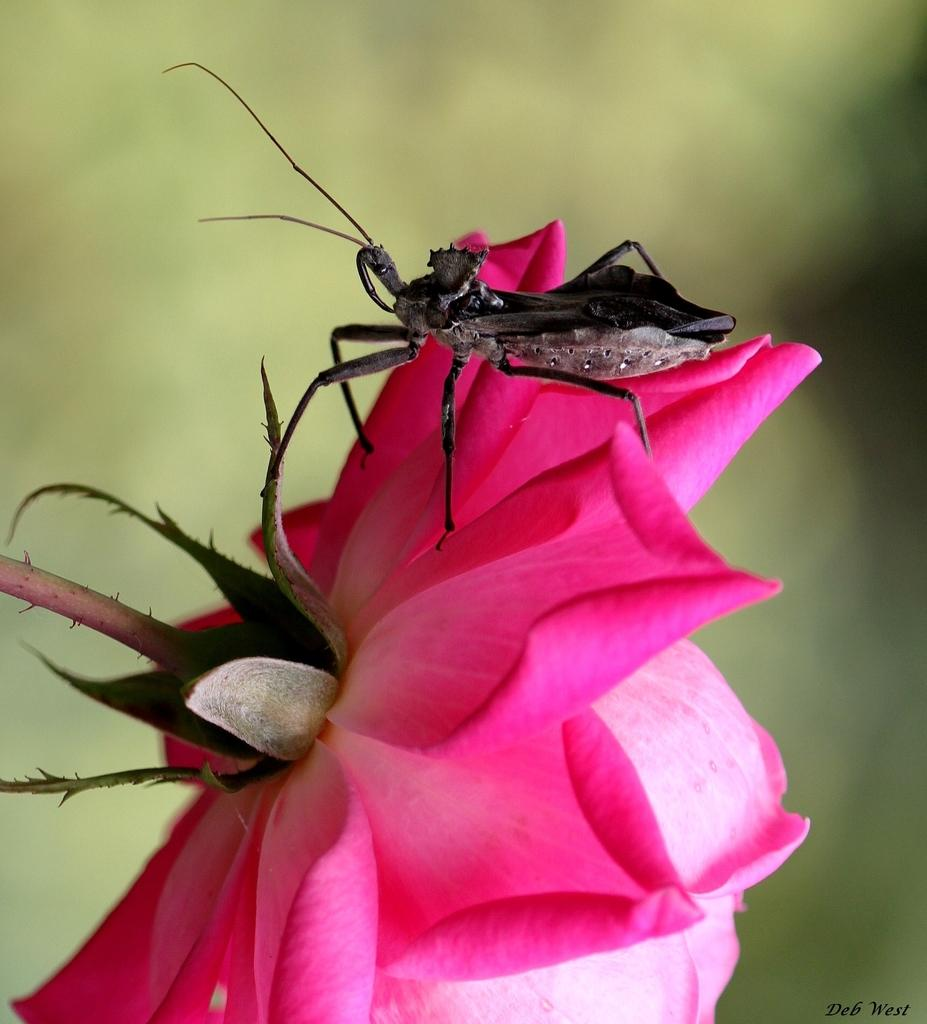What type of flower is in the image? There is a rose flower in the image. What else can be seen in the background of the image? There is an insect in the background of the image. How is the insect depicted in the image? The insect is blurred. What type of work is the insect doing in the image? There is no indication in the image that the insect is performing any work. 